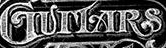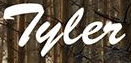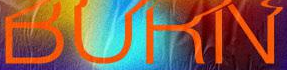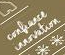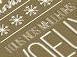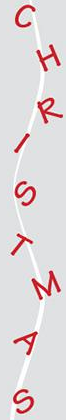What words can you see in these images in sequence, separated by a semicolon? GUITARS; Tyler; BURN; #; #; CHRISTMAS 